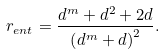Convert formula to latex. <formula><loc_0><loc_0><loc_500><loc_500>r _ { e n t } = \frac { d ^ { m } + d ^ { 2 } + 2 d } { \left ( d ^ { m } + d \right ) ^ { 2 } } .</formula> 